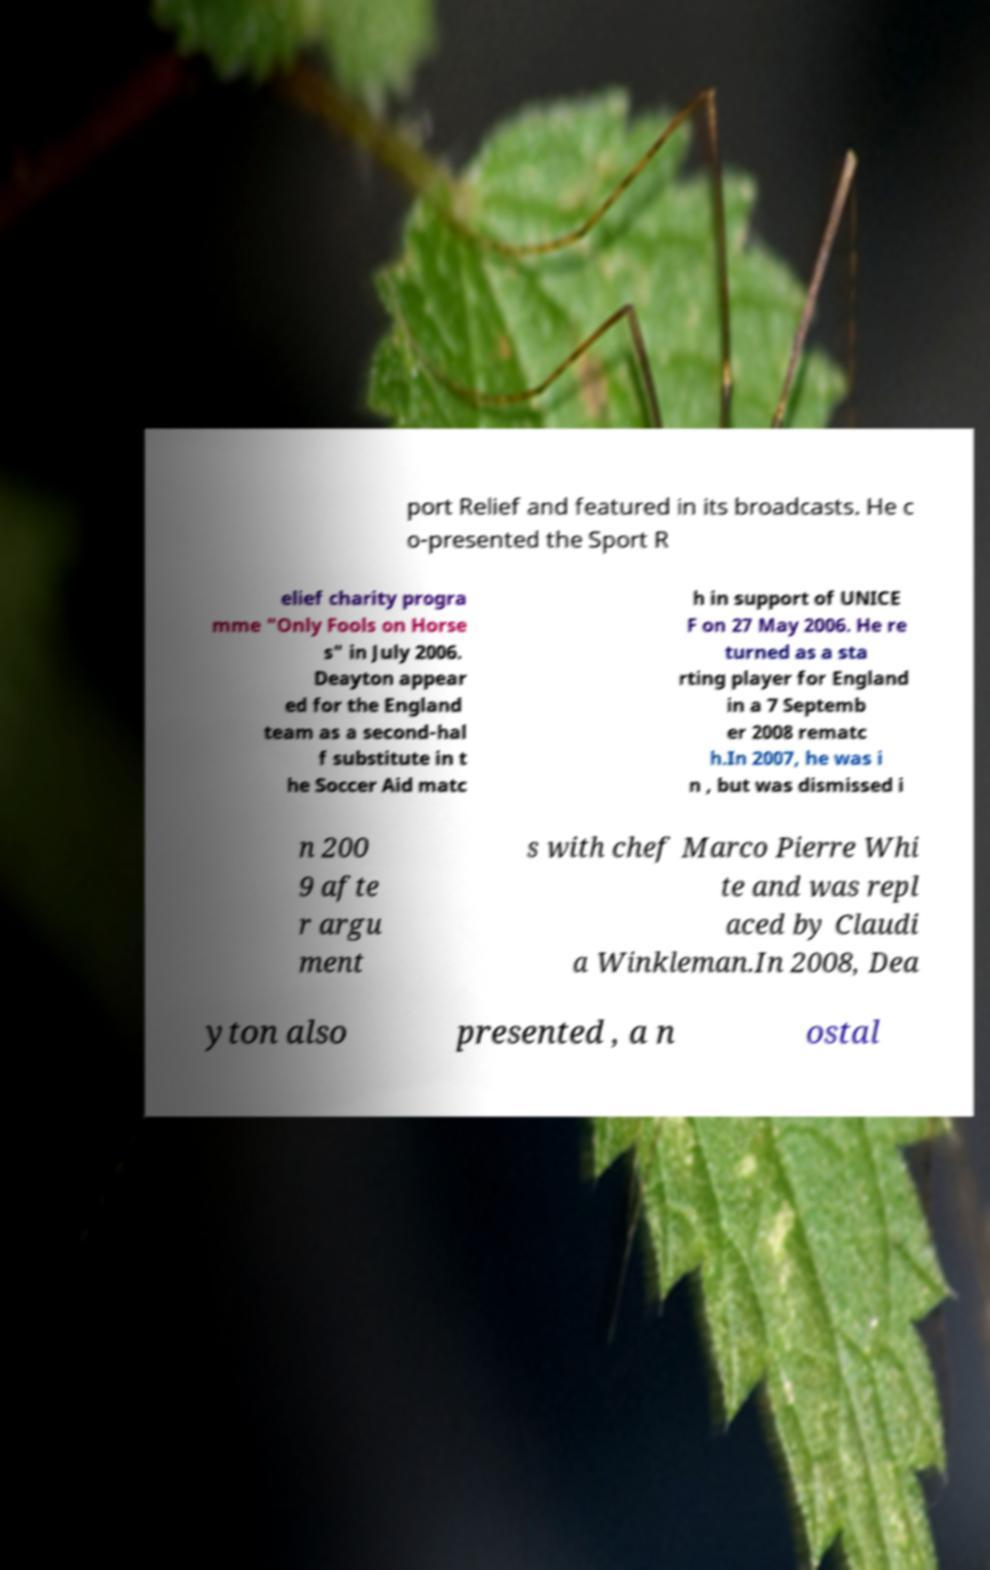What messages or text are displayed in this image? I need them in a readable, typed format. port Relief and featured in its broadcasts. He c o-presented the Sport R elief charity progra mme "Only Fools on Horse s" in July 2006. Deayton appear ed for the England team as a second-hal f substitute in t he Soccer Aid matc h in support of UNICE F on 27 May 2006. He re turned as a sta rting player for England in a 7 Septemb er 2008 rematc h.In 2007, he was i n , but was dismissed i n 200 9 afte r argu ment s with chef Marco Pierre Whi te and was repl aced by Claudi a Winkleman.In 2008, Dea yton also presented , a n ostal 